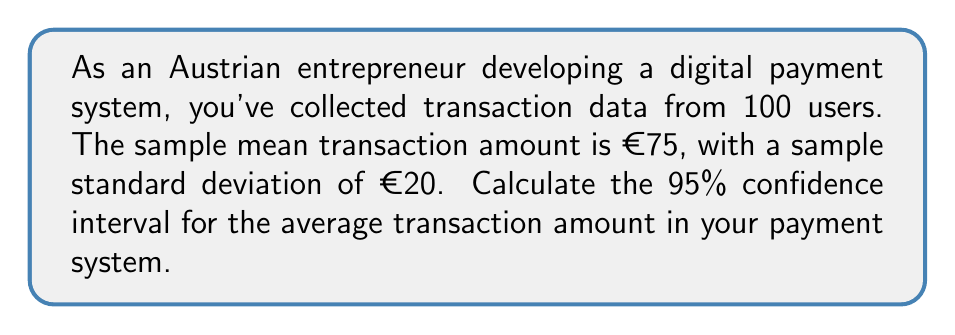Give your solution to this math problem. To calculate the confidence interval, we'll use the formula:

$$ \text{CI} = \bar{x} \pm t_{\alpha/2} \cdot \frac{s}{\sqrt{n}} $$

Where:
- $\bar{x}$ is the sample mean (€75)
- $s$ is the sample standard deviation (€20)
- $n$ is the sample size (100)
- $t_{\alpha/2}$ is the t-value for a 95% confidence interval with 99 degrees of freedom

Steps:
1) For a 95% CI with 99 degrees of freedom, $t_{\alpha/2} \approx 1.984$ (from t-distribution table)

2) Calculate the standard error:
   $$ SE = \frac{s}{\sqrt{n}} = \frac{20}{\sqrt{100}} = 2 $$

3) Calculate the margin of error:
   $$ ME = t_{\alpha/2} \cdot SE = 1.984 \cdot 2 = 3.968 $$

4) Calculate the confidence interval:
   $$ \text{CI} = 75 \pm 3.968 $$
   $$ \text{CI} = (71.032, 78.968) $$

Therefore, we can be 95% confident that the true average transaction amount in the payment system is between €71.03 and €78.97.
Answer: (€71.03, €78.97) 